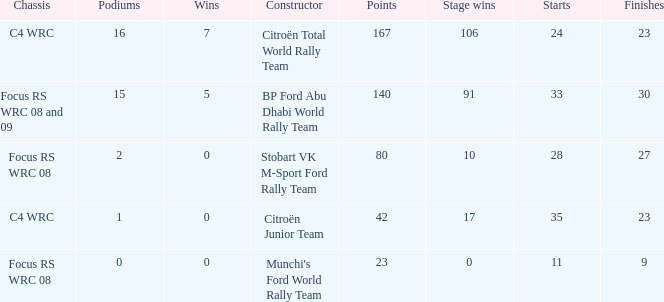What is the total number of points when the constructor is citroën total world rally team and the wins is less than 7? 0.0. 